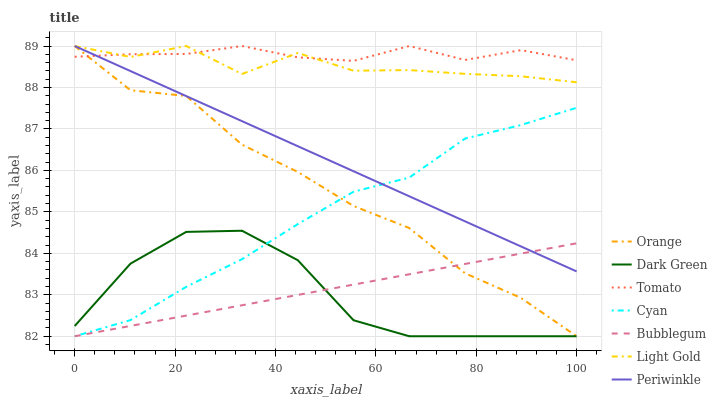Does Dark Green have the minimum area under the curve?
Answer yes or no. Yes. Does Tomato have the maximum area under the curve?
Answer yes or no. Yes. Does Bubblegum have the minimum area under the curve?
Answer yes or no. No. Does Bubblegum have the maximum area under the curve?
Answer yes or no. No. Is Bubblegum the smoothest?
Answer yes or no. Yes. Is Dark Green the roughest?
Answer yes or no. Yes. Is Periwinkle the smoothest?
Answer yes or no. No. Is Periwinkle the roughest?
Answer yes or no. No. Does Bubblegum have the lowest value?
Answer yes or no. Yes. Does Periwinkle have the lowest value?
Answer yes or no. No. Does Light Gold have the highest value?
Answer yes or no. Yes. Does Bubblegum have the highest value?
Answer yes or no. No. Is Dark Green less than Periwinkle?
Answer yes or no. Yes. Is Light Gold greater than Cyan?
Answer yes or no. Yes. Does Light Gold intersect Orange?
Answer yes or no. Yes. Is Light Gold less than Orange?
Answer yes or no. No. Is Light Gold greater than Orange?
Answer yes or no. No. Does Dark Green intersect Periwinkle?
Answer yes or no. No. 